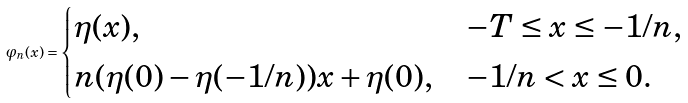<formula> <loc_0><loc_0><loc_500><loc_500>\varphi _ { n } ( x ) = \begin{cases} \eta ( x ) , & - T \leq x \leq - 1 / n , \\ n ( \eta ( 0 ) - \eta ( - 1 / n ) ) x + \eta ( 0 ) , & - 1 / n < x \leq 0 . \end{cases}</formula> 